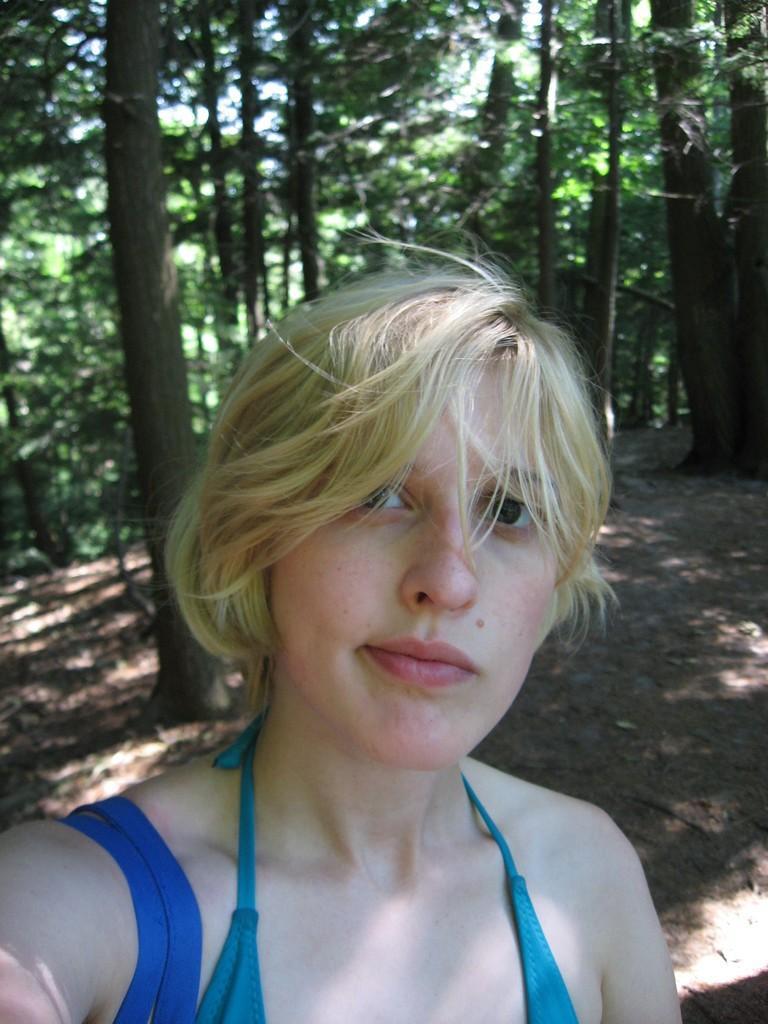How would you summarize this image in a sentence or two? In this image I can see a person. Back I can see few green trees. 